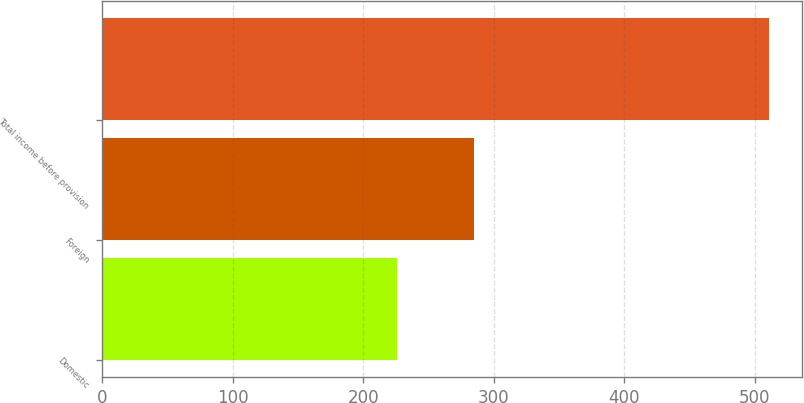<chart> <loc_0><loc_0><loc_500><loc_500><bar_chart><fcel>Domestic<fcel>Foreign<fcel>Total income before provision<nl><fcel>225.9<fcel>284.7<fcel>510.6<nl></chart> 